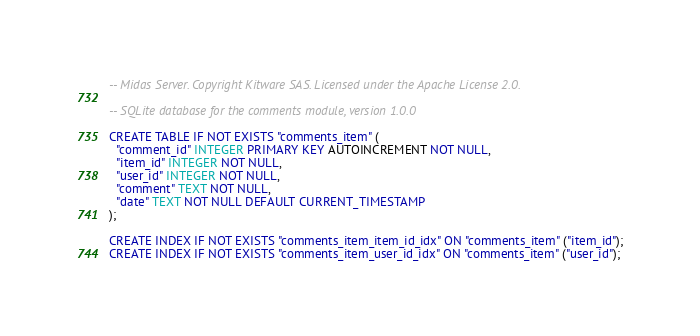Convert code to text. <code><loc_0><loc_0><loc_500><loc_500><_SQL_>-- Midas Server. Copyright Kitware SAS. Licensed under the Apache License 2.0.

-- SQLite database for the comments module, version 1.0.0

CREATE TABLE IF NOT EXISTS "comments_item" (
  "comment_id" INTEGER PRIMARY KEY AUTOINCREMENT NOT NULL,
  "item_id" INTEGER NOT NULL,
  "user_id" INTEGER NOT NULL,
  "comment" TEXT NOT NULL,
  "date" TEXT NOT NULL DEFAULT CURRENT_TIMESTAMP
);

CREATE INDEX IF NOT EXISTS "comments_item_item_id_idx" ON "comments_item" ("item_id");
CREATE INDEX IF NOT EXISTS "comments_item_user_id_idx" ON "comments_item" ("user_id");
</code> 